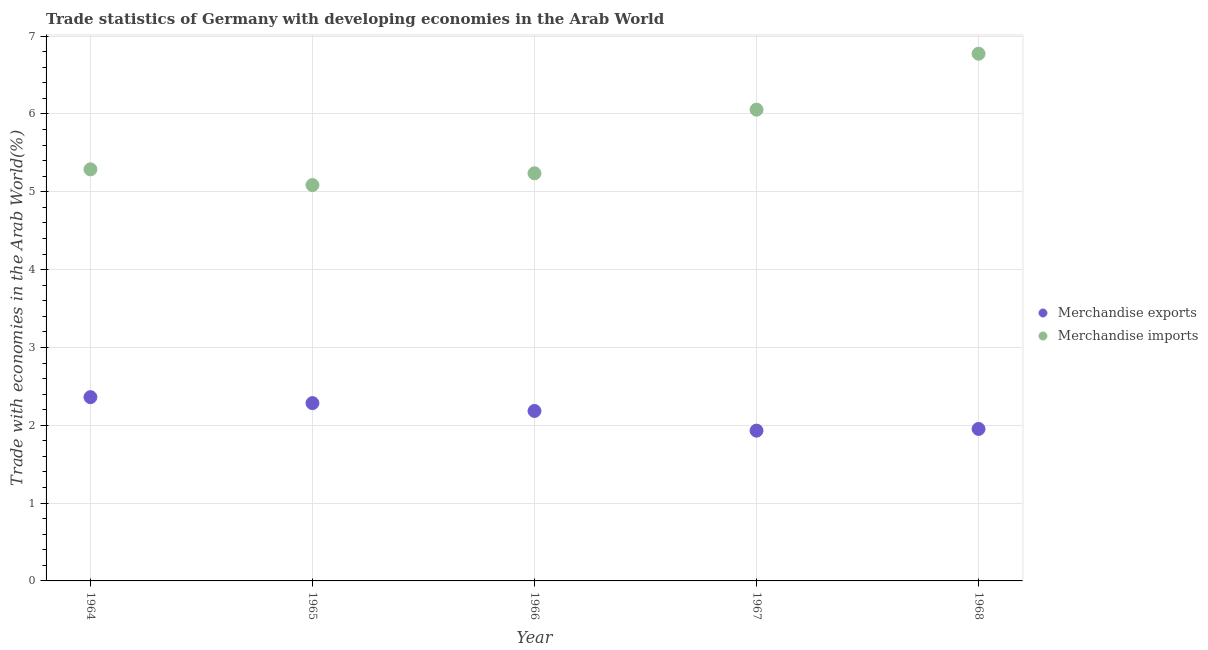How many different coloured dotlines are there?
Keep it short and to the point. 2. What is the merchandise exports in 1967?
Make the answer very short. 1.93. Across all years, what is the maximum merchandise exports?
Offer a terse response. 2.36. Across all years, what is the minimum merchandise imports?
Keep it short and to the point. 5.09. In which year was the merchandise exports maximum?
Make the answer very short. 1964. In which year was the merchandise exports minimum?
Ensure brevity in your answer.  1967. What is the total merchandise exports in the graph?
Keep it short and to the point. 10.71. What is the difference between the merchandise exports in 1964 and that in 1967?
Provide a succinct answer. 0.43. What is the difference between the merchandise exports in 1966 and the merchandise imports in 1965?
Provide a short and direct response. -2.9. What is the average merchandise imports per year?
Keep it short and to the point. 5.69. In the year 1967, what is the difference between the merchandise imports and merchandise exports?
Provide a short and direct response. 4.12. What is the ratio of the merchandise exports in 1964 to that in 1968?
Provide a short and direct response. 1.21. What is the difference between the highest and the second highest merchandise exports?
Provide a succinct answer. 0.08. What is the difference between the highest and the lowest merchandise imports?
Your answer should be compact. 1.69. In how many years, is the merchandise imports greater than the average merchandise imports taken over all years?
Your answer should be very brief. 2. Is the sum of the merchandise exports in 1964 and 1967 greater than the maximum merchandise imports across all years?
Keep it short and to the point. No. How many dotlines are there?
Ensure brevity in your answer.  2. How many years are there in the graph?
Ensure brevity in your answer.  5. What is the difference between two consecutive major ticks on the Y-axis?
Your answer should be very brief. 1. Are the values on the major ticks of Y-axis written in scientific E-notation?
Offer a very short reply. No. Does the graph contain any zero values?
Offer a very short reply. No. Does the graph contain grids?
Provide a short and direct response. Yes. Where does the legend appear in the graph?
Give a very brief answer. Center right. How many legend labels are there?
Ensure brevity in your answer.  2. How are the legend labels stacked?
Provide a short and direct response. Vertical. What is the title of the graph?
Offer a terse response. Trade statistics of Germany with developing economies in the Arab World. What is the label or title of the Y-axis?
Keep it short and to the point. Trade with economies in the Arab World(%). What is the Trade with economies in the Arab World(%) in Merchandise exports in 1964?
Your answer should be very brief. 2.36. What is the Trade with economies in the Arab World(%) in Merchandise imports in 1964?
Ensure brevity in your answer.  5.29. What is the Trade with economies in the Arab World(%) of Merchandise exports in 1965?
Provide a succinct answer. 2.28. What is the Trade with economies in the Arab World(%) of Merchandise imports in 1965?
Keep it short and to the point. 5.09. What is the Trade with economies in the Arab World(%) in Merchandise exports in 1966?
Offer a terse response. 2.18. What is the Trade with economies in the Arab World(%) of Merchandise imports in 1966?
Your response must be concise. 5.24. What is the Trade with economies in the Arab World(%) of Merchandise exports in 1967?
Offer a very short reply. 1.93. What is the Trade with economies in the Arab World(%) in Merchandise imports in 1967?
Your answer should be very brief. 6.06. What is the Trade with economies in the Arab World(%) in Merchandise exports in 1968?
Make the answer very short. 1.95. What is the Trade with economies in the Arab World(%) of Merchandise imports in 1968?
Your answer should be very brief. 6.77. Across all years, what is the maximum Trade with economies in the Arab World(%) of Merchandise exports?
Keep it short and to the point. 2.36. Across all years, what is the maximum Trade with economies in the Arab World(%) in Merchandise imports?
Your response must be concise. 6.77. Across all years, what is the minimum Trade with economies in the Arab World(%) in Merchandise exports?
Give a very brief answer. 1.93. Across all years, what is the minimum Trade with economies in the Arab World(%) of Merchandise imports?
Your response must be concise. 5.09. What is the total Trade with economies in the Arab World(%) in Merchandise exports in the graph?
Make the answer very short. 10.71. What is the total Trade with economies in the Arab World(%) in Merchandise imports in the graph?
Offer a very short reply. 28.44. What is the difference between the Trade with economies in the Arab World(%) of Merchandise exports in 1964 and that in 1965?
Your response must be concise. 0.08. What is the difference between the Trade with economies in the Arab World(%) in Merchandise imports in 1964 and that in 1965?
Offer a very short reply. 0.2. What is the difference between the Trade with economies in the Arab World(%) of Merchandise exports in 1964 and that in 1966?
Your answer should be very brief. 0.18. What is the difference between the Trade with economies in the Arab World(%) in Merchandise imports in 1964 and that in 1966?
Make the answer very short. 0.05. What is the difference between the Trade with economies in the Arab World(%) of Merchandise exports in 1964 and that in 1967?
Keep it short and to the point. 0.43. What is the difference between the Trade with economies in the Arab World(%) of Merchandise imports in 1964 and that in 1967?
Keep it short and to the point. -0.77. What is the difference between the Trade with economies in the Arab World(%) of Merchandise exports in 1964 and that in 1968?
Your response must be concise. 0.41. What is the difference between the Trade with economies in the Arab World(%) of Merchandise imports in 1964 and that in 1968?
Provide a short and direct response. -1.49. What is the difference between the Trade with economies in the Arab World(%) of Merchandise exports in 1965 and that in 1966?
Offer a terse response. 0.1. What is the difference between the Trade with economies in the Arab World(%) of Merchandise imports in 1965 and that in 1966?
Make the answer very short. -0.15. What is the difference between the Trade with economies in the Arab World(%) of Merchandise exports in 1965 and that in 1967?
Offer a terse response. 0.35. What is the difference between the Trade with economies in the Arab World(%) in Merchandise imports in 1965 and that in 1967?
Offer a terse response. -0.97. What is the difference between the Trade with economies in the Arab World(%) of Merchandise exports in 1965 and that in 1968?
Your answer should be compact. 0.33. What is the difference between the Trade with economies in the Arab World(%) of Merchandise imports in 1965 and that in 1968?
Provide a succinct answer. -1.69. What is the difference between the Trade with economies in the Arab World(%) of Merchandise exports in 1966 and that in 1967?
Ensure brevity in your answer.  0.25. What is the difference between the Trade with economies in the Arab World(%) of Merchandise imports in 1966 and that in 1967?
Offer a terse response. -0.82. What is the difference between the Trade with economies in the Arab World(%) of Merchandise exports in 1966 and that in 1968?
Keep it short and to the point. 0.23. What is the difference between the Trade with economies in the Arab World(%) in Merchandise imports in 1966 and that in 1968?
Ensure brevity in your answer.  -1.54. What is the difference between the Trade with economies in the Arab World(%) in Merchandise exports in 1967 and that in 1968?
Offer a very short reply. -0.02. What is the difference between the Trade with economies in the Arab World(%) in Merchandise imports in 1967 and that in 1968?
Provide a succinct answer. -0.72. What is the difference between the Trade with economies in the Arab World(%) in Merchandise exports in 1964 and the Trade with economies in the Arab World(%) in Merchandise imports in 1965?
Your answer should be compact. -2.73. What is the difference between the Trade with economies in the Arab World(%) in Merchandise exports in 1964 and the Trade with economies in the Arab World(%) in Merchandise imports in 1966?
Make the answer very short. -2.88. What is the difference between the Trade with economies in the Arab World(%) of Merchandise exports in 1964 and the Trade with economies in the Arab World(%) of Merchandise imports in 1967?
Offer a terse response. -3.69. What is the difference between the Trade with economies in the Arab World(%) of Merchandise exports in 1964 and the Trade with economies in the Arab World(%) of Merchandise imports in 1968?
Give a very brief answer. -4.41. What is the difference between the Trade with economies in the Arab World(%) of Merchandise exports in 1965 and the Trade with economies in the Arab World(%) of Merchandise imports in 1966?
Provide a succinct answer. -2.95. What is the difference between the Trade with economies in the Arab World(%) of Merchandise exports in 1965 and the Trade with economies in the Arab World(%) of Merchandise imports in 1967?
Your response must be concise. -3.77. What is the difference between the Trade with economies in the Arab World(%) of Merchandise exports in 1965 and the Trade with economies in the Arab World(%) of Merchandise imports in 1968?
Offer a very short reply. -4.49. What is the difference between the Trade with economies in the Arab World(%) in Merchandise exports in 1966 and the Trade with economies in the Arab World(%) in Merchandise imports in 1967?
Give a very brief answer. -3.87. What is the difference between the Trade with economies in the Arab World(%) in Merchandise exports in 1966 and the Trade with economies in the Arab World(%) in Merchandise imports in 1968?
Provide a short and direct response. -4.59. What is the difference between the Trade with economies in the Arab World(%) in Merchandise exports in 1967 and the Trade with economies in the Arab World(%) in Merchandise imports in 1968?
Give a very brief answer. -4.84. What is the average Trade with economies in the Arab World(%) of Merchandise exports per year?
Give a very brief answer. 2.14. What is the average Trade with economies in the Arab World(%) of Merchandise imports per year?
Provide a succinct answer. 5.69. In the year 1964, what is the difference between the Trade with economies in the Arab World(%) in Merchandise exports and Trade with economies in the Arab World(%) in Merchandise imports?
Provide a short and direct response. -2.93. In the year 1965, what is the difference between the Trade with economies in the Arab World(%) in Merchandise exports and Trade with economies in the Arab World(%) in Merchandise imports?
Your response must be concise. -2.8. In the year 1966, what is the difference between the Trade with economies in the Arab World(%) of Merchandise exports and Trade with economies in the Arab World(%) of Merchandise imports?
Make the answer very short. -3.05. In the year 1967, what is the difference between the Trade with economies in the Arab World(%) in Merchandise exports and Trade with economies in the Arab World(%) in Merchandise imports?
Make the answer very short. -4.12. In the year 1968, what is the difference between the Trade with economies in the Arab World(%) of Merchandise exports and Trade with economies in the Arab World(%) of Merchandise imports?
Make the answer very short. -4.82. What is the ratio of the Trade with economies in the Arab World(%) in Merchandise exports in 1964 to that in 1965?
Ensure brevity in your answer.  1.03. What is the ratio of the Trade with economies in the Arab World(%) in Merchandise imports in 1964 to that in 1965?
Give a very brief answer. 1.04. What is the ratio of the Trade with economies in the Arab World(%) in Merchandise exports in 1964 to that in 1966?
Make the answer very short. 1.08. What is the ratio of the Trade with economies in the Arab World(%) in Merchandise imports in 1964 to that in 1966?
Provide a short and direct response. 1.01. What is the ratio of the Trade with economies in the Arab World(%) in Merchandise exports in 1964 to that in 1967?
Make the answer very short. 1.22. What is the ratio of the Trade with economies in the Arab World(%) in Merchandise imports in 1964 to that in 1967?
Give a very brief answer. 0.87. What is the ratio of the Trade with economies in the Arab World(%) in Merchandise exports in 1964 to that in 1968?
Keep it short and to the point. 1.21. What is the ratio of the Trade with economies in the Arab World(%) in Merchandise imports in 1964 to that in 1968?
Your answer should be very brief. 0.78. What is the ratio of the Trade with economies in the Arab World(%) of Merchandise exports in 1965 to that in 1966?
Provide a short and direct response. 1.05. What is the ratio of the Trade with economies in the Arab World(%) in Merchandise imports in 1965 to that in 1966?
Your response must be concise. 0.97. What is the ratio of the Trade with economies in the Arab World(%) of Merchandise exports in 1965 to that in 1967?
Give a very brief answer. 1.18. What is the ratio of the Trade with economies in the Arab World(%) in Merchandise imports in 1965 to that in 1967?
Offer a terse response. 0.84. What is the ratio of the Trade with economies in the Arab World(%) of Merchandise exports in 1965 to that in 1968?
Ensure brevity in your answer.  1.17. What is the ratio of the Trade with economies in the Arab World(%) of Merchandise imports in 1965 to that in 1968?
Your answer should be compact. 0.75. What is the ratio of the Trade with economies in the Arab World(%) in Merchandise exports in 1966 to that in 1967?
Offer a terse response. 1.13. What is the ratio of the Trade with economies in the Arab World(%) in Merchandise imports in 1966 to that in 1967?
Your answer should be very brief. 0.86. What is the ratio of the Trade with economies in the Arab World(%) in Merchandise exports in 1966 to that in 1968?
Offer a very short reply. 1.12. What is the ratio of the Trade with economies in the Arab World(%) in Merchandise imports in 1966 to that in 1968?
Make the answer very short. 0.77. What is the ratio of the Trade with economies in the Arab World(%) in Merchandise exports in 1967 to that in 1968?
Provide a succinct answer. 0.99. What is the ratio of the Trade with economies in the Arab World(%) in Merchandise imports in 1967 to that in 1968?
Your answer should be compact. 0.89. What is the difference between the highest and the second highest Trade with economies in the Arab World(%) of Merchandise exports?
Offer a terse response. 0.08. What is the difference between the highest and the second highest Trade with economies in the Arab World(%) of Merchandise imports?
Ensure brevity in your answer.  0.72. What is the difference between the highest and the lowest Trade with economies in the Arab World(%) of Merchandise exports?
Provide a short and direct response. 0.43. What is the difference between the highest and the lowest Trade with economies in the Arab World(%) in Merchandise imports?
Provide a succinct answer. 1.69. 